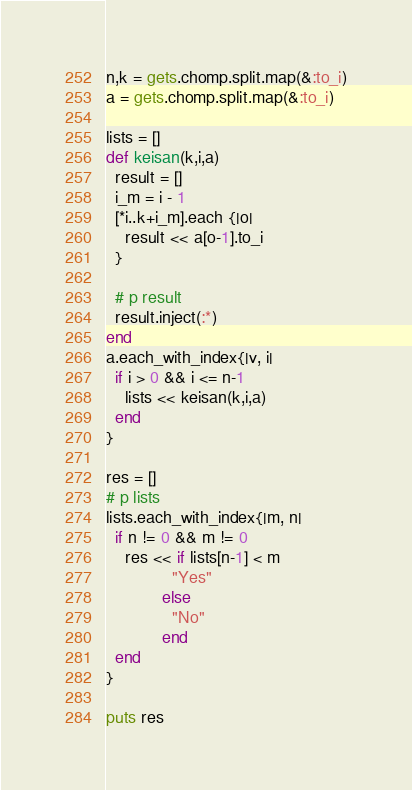Convert code to text. <code><loc_0><loc_0><loc_500><loc_500><_Ruby_>n,k = gets.chomp.split.map(&:to_i)
a = gets.chomp.split.map(&:to_i)

lists = []
def keisan(k,i,a)
  result = []
  i_m = i - 1
  [*i..k+i_m].each {|o|
    result << a[o-1].to_i
  }

  # p result
  result.inject(:*)
end
a.each_with_index{|v, i|
  if i > 0 && i <= n-1
    lists << keisan(k,i,a)
  end
}

res = []
# p lists
lists.each_with_index{|m, n|
  if n != 0 && m != 0
    res << if lists[n-1] < m
              "Yes"
            else
              "No"
            end
  end
}

puts res</code> 